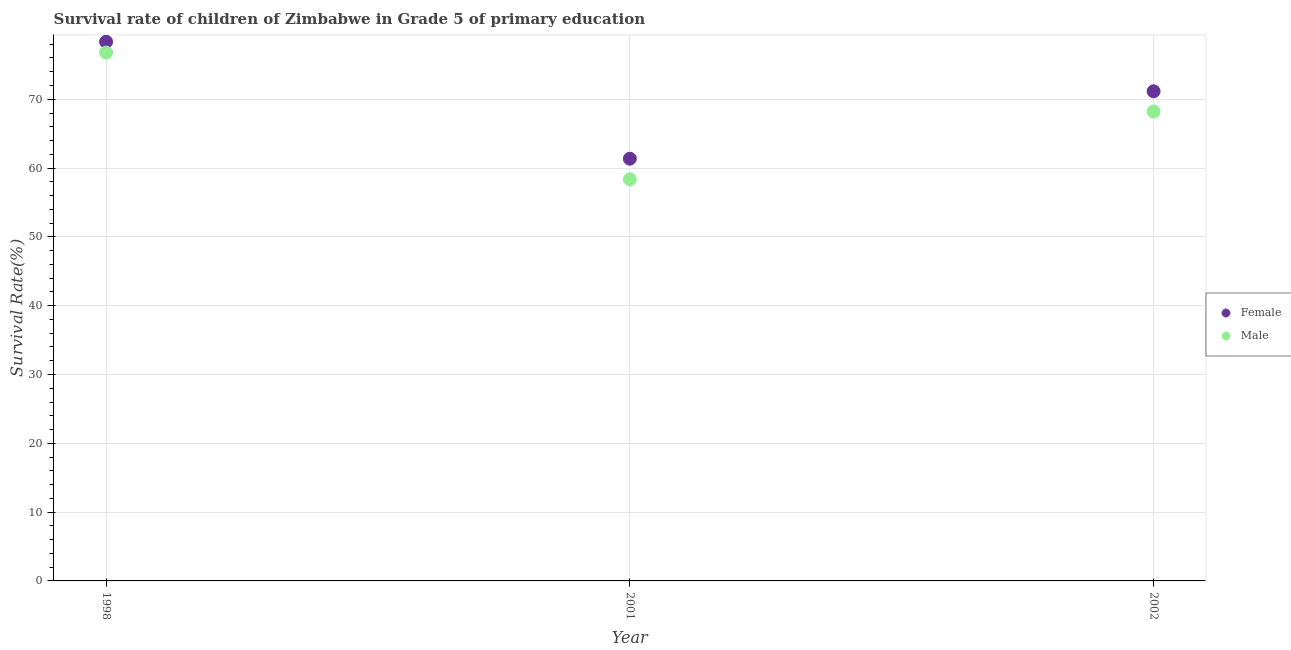How many different coloured dotlines are there?
Provide a succinct answer. 2. Is the number of dotlines equal to the number of legend labels?
Ensure brevity in your answer.  Yes. What is the survival rate of male students in primary education in 2001?
Make the answer very short. 58.37. Across all years, what is the maximum survival rate of male students in primary education?
Provide a short and direct response. 76.79. Across all years, what is the minimum survival rate of female students in primary education?
Your response must be concise. 61.36. In which year was the survival rate of male students in primary education minimum?
Keep it short and to the point. 2001. What is the total survival rate of male students in primary education in the graph?
Make the answer very short. 203.38. What is the difference between the survival rate of male students in primary education in 1998 and that in 2002?
Offer a very short reply. 8.57. What is the difference between the survival rate of male students in primary education in 2001 and the survival rate of female students in primary education in 2002?
Offer a very short reply. -12.8. What is the average survival rate of female students in primary education per year?
Make the answer very short. 70.29. In the year 2001, what is the difference between the survival rate of male students in primary education and survival rate of female students in primary education?
Your response must be concise. -3. What is the ratio of the survival rate of male students in primary education in 1998 to that in 2001?
Offer a very short reply. 1.32. Is the difference between the survival rate of female students in primary education in 1998 and 2001 greater than the difference between the survival rate of male students in primary education in 1998 and 2001?
Your response must be concise. No. What is the difference between the highest and the second highest survival rate of female students in primary education?
Offer a very short reply. 7.2. What is the difference between the highest and the lowest survival rate of female students in primary education?
Your answer should be compact. 16.99. In how many years, is the survival rate of female students in primary education greater than the average survival rate of female students in primary education taken over all years?
Make the answer very short. 2. Is the sum of the survival rate of male students in primary education in 1998 and 2001 greater than the maximum survival rate of female students in primary education across all years?
Offer a terse response. Yes. How many dotlines are there?
Provide a succinct answer. 2. Are the values on the major ticks of Y-axis written in scientific E-notation?
Offer a very short reply. No. Does the graph contain any zero values?
Offer a very short reply. No. How many legend labels are there?
Provide a succinct answer. 2. How are the legend labels stacked?
Offer a terse response. Vertical. What is the title of the graph?
Your answer should be very brief. Survival rate of children of Zimbabwe in Grade 5 of primary education. Does "External balance on goods" appear as one of the legend labels in the graph?
Give a very brief answer. No. What is the label or title of the Y-axis?
Offer a terse response. Survival Rate(%). What is the Survival Rate(%) of Female in 1998?
Offer a very short reply. 78.36. What is the Survival Rate(%) of Male in 1998?
Ensure brevity in your answer.  76.79. What is the Survival Rate(%) in Female in 2001?
Offer a very short reply. 61.36. What is the Survival Rate(%) of Male in 2001?
Ensure brevity in your answer.  58.37. What is the Survival Rate(%) of Female in 2002?
Offer a very short reply. 71.16. What is the Survival Rate(%) in Male in 2002?
Provide a short and direct response. 68.23. Across all years, what is the maximum Survival Rate(%) in Female?
Offer a terse response. 78.36. Across all years, what is the maximum Survival Rate(%) of Male?
Your answer should be very brief. 76.79. Across all years, what is the minimum Survival Rate(%) of Female?
Offer a terse response. 61.36. Across all years, what is the minimum Survival Rate(%) in Male?
Your response must be concise. 58.37. What is the total Survival Rate(%) of Female in the graph?
Provide a short and direct response. 210.88. What is the total Survival Rate(%) in Male in the graph?
Give a very brief answer. 203.38. What is the difference between the Survival Rate(%) of Female in 1998 and that in 2001?
Your response must be concise. 16.99. What is the difference between the Survival Rate(%) of Male in 1998 and that in 2001?
Your response must be concise. 18.43. What is the difference between the Survival Rate(%) in Female in 1998 and that in 2002?
Offer a terse response. 7.2. What is the difference between the Survival Rate(%) in Male in 1998 and that in 2002?
Offer a terse response. 8.57. What is the difference between the Survival Rate(%) of Female in 2001 and that in 2002?
Provide a short and direct response. -9.8. What is the difference between the Survival Rate(%) of Male in 2001 and that in 2002?
Your answer should be very brief. -9.86. What is the difference between the Survival Rate(%) of Female in 1998 and the Survival Rate(%) of Male in 2001?
Make the answer very short. 19.99. What is the difference between the Survival Rate(%) of Female in 1998 and the Survival Rate(%) of Male in 2002?
Make the answer very short. 10.13. What is the difference between the Survival Rate(%) in Female in 2001 and the Survival Rate(%) in Male in 2002?
Keep it short and to the point. -6.86. What is the average Survival Rate(%) of Female per year?
Make the answer very short. 70.29. What is the average Survival Rate(%) of Male per year?
Offer a very short reply. 67.79. In the year 1998, what is the difference between the Survival Rate(%) of Female and Survival Rate(%) of Male?
Provide a succinct answer. 1.57. In the year 2001, what is the difference between the Survival Rate(%) of Female and Survival Rate(%) of Male?
Make the answer very short. 3. In the year 2002, what is the difference between the Survival Rate(%) in Female and Survival Rate(%) in Male?
Keep it short and to the point. 2.93. What is the ratio of the Survival Rate(%) in Female in 1998 to that in 2001?
Your response must be concise. 1.28. What is the ratio of the Survival Rate(%) of Male in 1998 to that in 2001?
Your answer should be very brief. 1.32. What is the ratio of the Survival Rate(%) of Female in 1998 to that in 2002?
Your answer should be very brief. 1.1. What is the ratio of the Survival Rate(%) in Male in 1998 to that in 2002?
Provide a succinct answer. 1.13. What is the ratio of the Survival Rate(%) of Female in 2001 to that in 2002?
Provide a succinct answer. 0.86. What is the ratio of the Survival Rate(%) of Male in 2001 to that in 2002?
Your answer should be very brief. 0.86. What is the difference between the highest and the second highest Survival Rate(%) of Female?
Your answer should be very brief. 7.2. What is the difference between the highest and the second highest Survival Rate(%) of Male?
Provide a short and direct response. 8.57. What is the difference between the highest and the lowest Survival Rate(%) of Female?
Keep it short and to the point. 16.99. What is the difference between the highest and the lowest Survival Rate(%) of Male?
Provide a short and direct response. 18.43. 